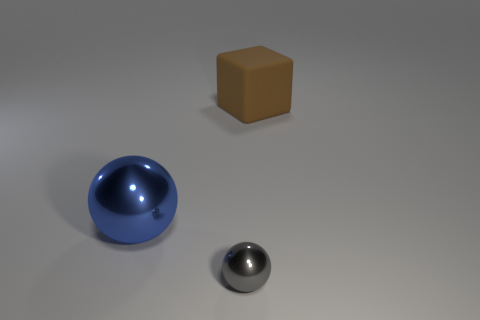What is the material of the sphere in front of the big thing in front of the large block?
Your answer should be very brief. Metal. What number of things are behind the small metallic ball and to the right of the blue sphere?
Give a very brief answer. 1. What number of other objects are there of the same size as the brown matte cube?
Make the answer very short. 1. There is a tiny object that is right of the large metal thing; is it the same shape as the object that is behind the large sphere?
Give a very brief answer. No. Are there any small shiny spheres on the right side of the cube?
Give a very brief answer. No. What is the color of the other metallic thing that is the same shape as the gray metallic object?
Offer a terse response. Blue. Is there anything else that is the same shape as the gray object?
Your answer should be compact. Yes. There is a large object that is in front of the large brown block; what is its material?
Your answer should be compact. Metal. The other blue thing that is the same shape as the tiny object is what size?
Give a very brief answer. Large. What number of large brown objects have the same material as the brown block?
Offer a very short reply. 0. 